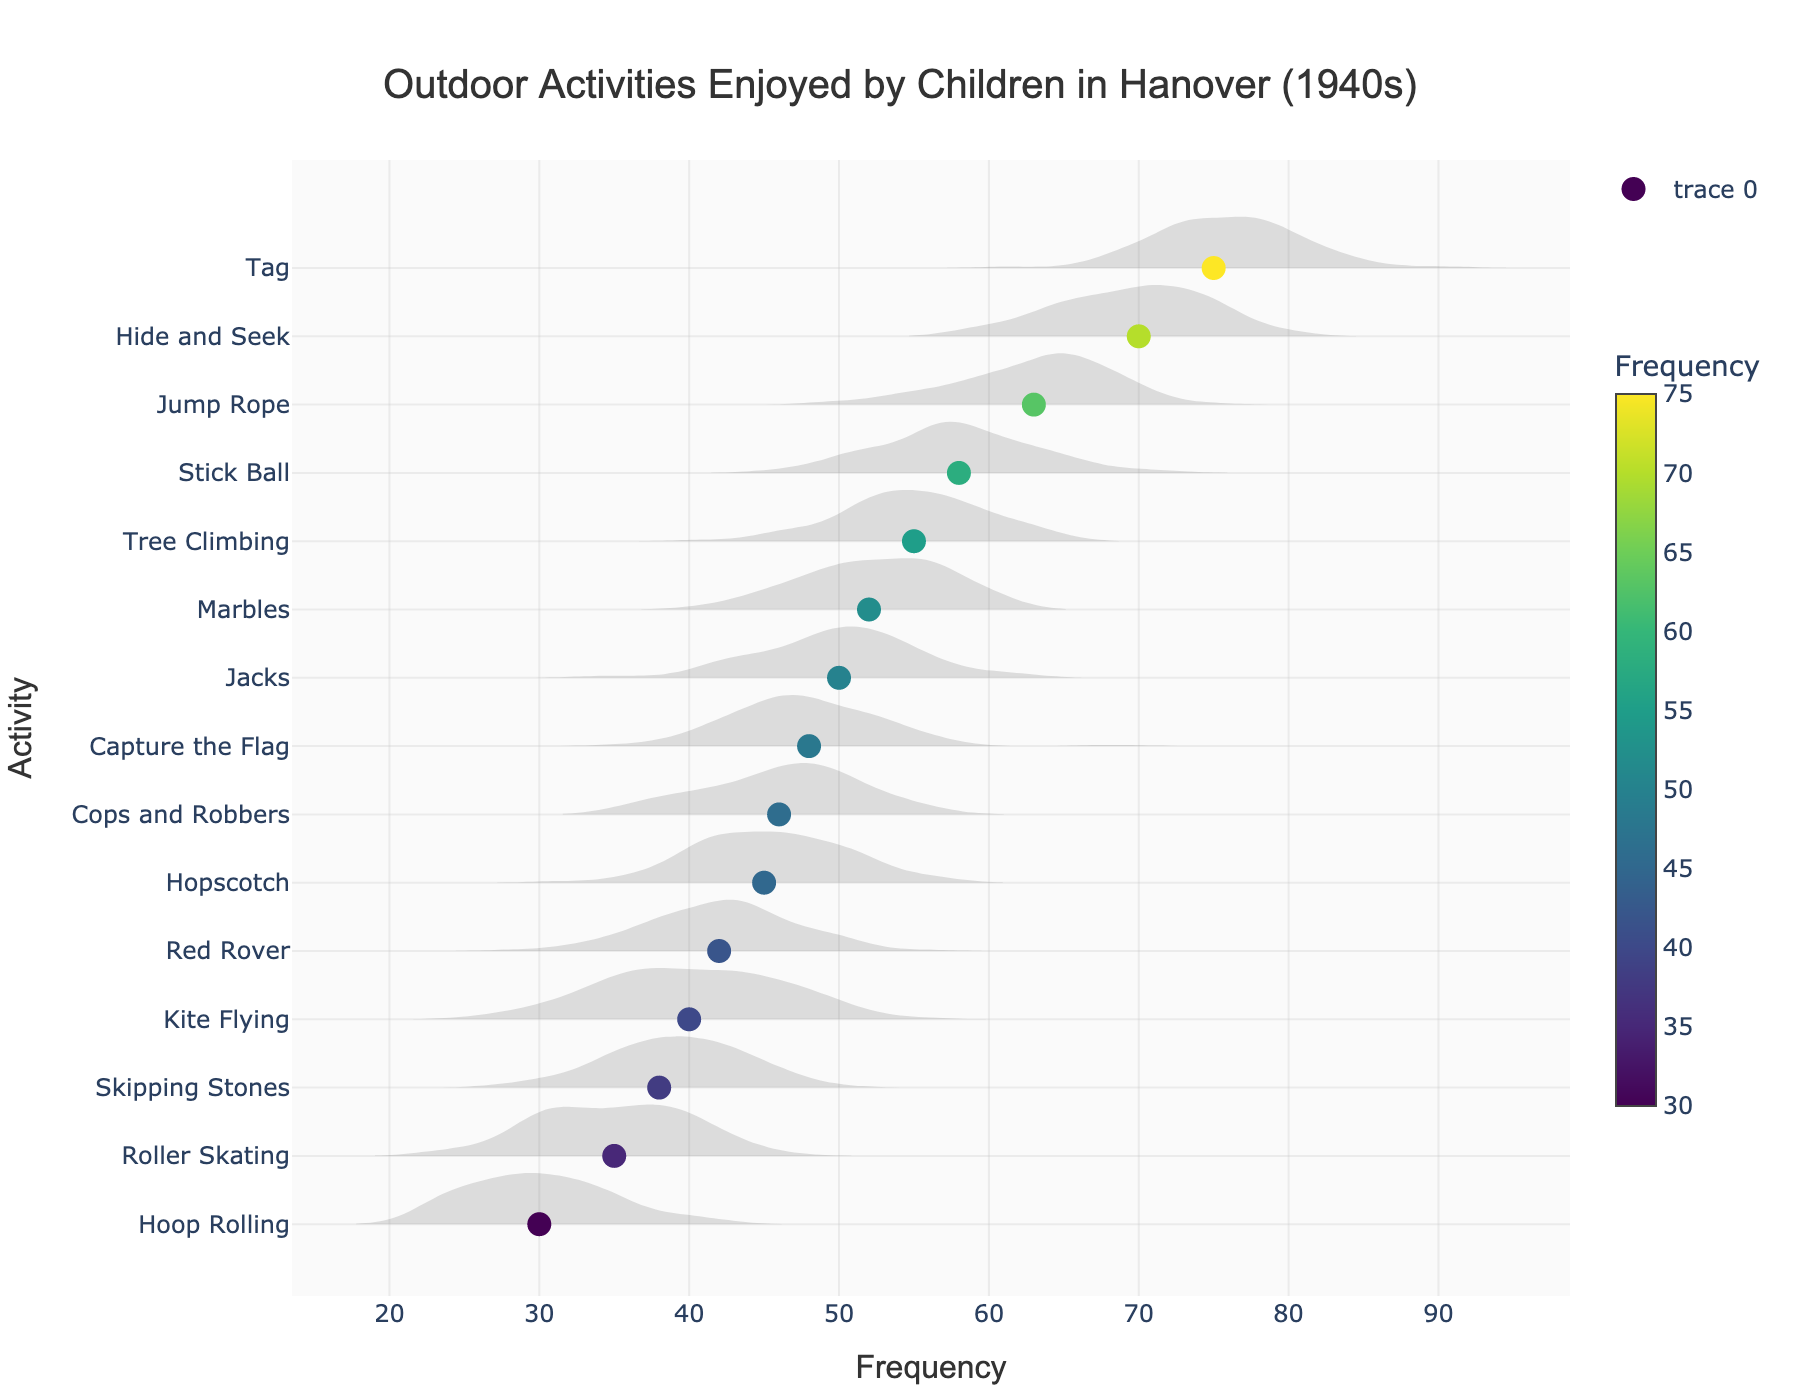What activity has the highest frequency? By examining the horizontal density plot, the activity with the highest frequency is the one with the longest bar on the x-axis. The activity 'Tag' appears to have the longest bar pointing to a frequency of 75.
Answer: Tag Which activities have a frequency greater than 60? To answer this, we identify all activities in the plot where the bar extends beyond the 60 mark on the x-axis. The activities 'Jump Rope', 'Hide and Seek', and 'Tag' all have frequencies greater than 60.
Answer: Jump Rope, Hide and Seek, Tag What is the frequency of 'Kite Flying'? Referencing the horizontal bar for 'Kite Flying', its end point determines the frequency. The bar for 'Kite Flying' points to 40 on the x-axis.
Answer: 40 Which activity has the lowest frequency? To find the activity with the lowest frequency, we look for the shortest bar in the plot. 'Hoop Rolling' appears to have the shortest bar pointing to a frequency of 30.
Answer: Hoop Rolling How does the frequency of 'Marbles' compare to 'Jacks'? By comparing the bars, 'Marbles' has a frequency of 52, while 'Jacks' has a frequency of 50. So, 'Marbles' is slightly higher.
Answer: Marbles is slightly higher What is the average frequency of 'Hide and Seek' and 'Tag'? Add frequencies of 'Hide and Seek' (70) and 'Tag' (75), then divide by 2 to find the average: (70 + 75) / 2 = 72.5.
Answer: 72.5 Which activities have a frequency between 40 and 50? Identify bars that fall within the 40 and 50 range on the x-axis. The activities are 'Kite Flying', 'Jacks', and 'Capture the Flag'.
Answer: Kite Flying, Jacks, Capture the Flag Are there more activities with frequencies above or below the median? First, find the median of frequencies (the middle value in the sorted list). If the list has an odd number of observations, the median is the middle number. If even, it’s the average of the two middle numbers. Here, the median of [30, 35, 38, 40, 42, 45, 46, 48, 50, 52, 55, 58, 63, 70, 75] is 48. Count how many activities have frequencies above and below 48. There are 7 activities below and 8 above.
Answer: More activities above What is the range of frequencies for these activities? Subtract the lowest frequency (30 for 'Hoop Rolling') from the highest frequency (75 for 'Tag'). The calculation is 75 - 30 = 45.
Answer: 45 